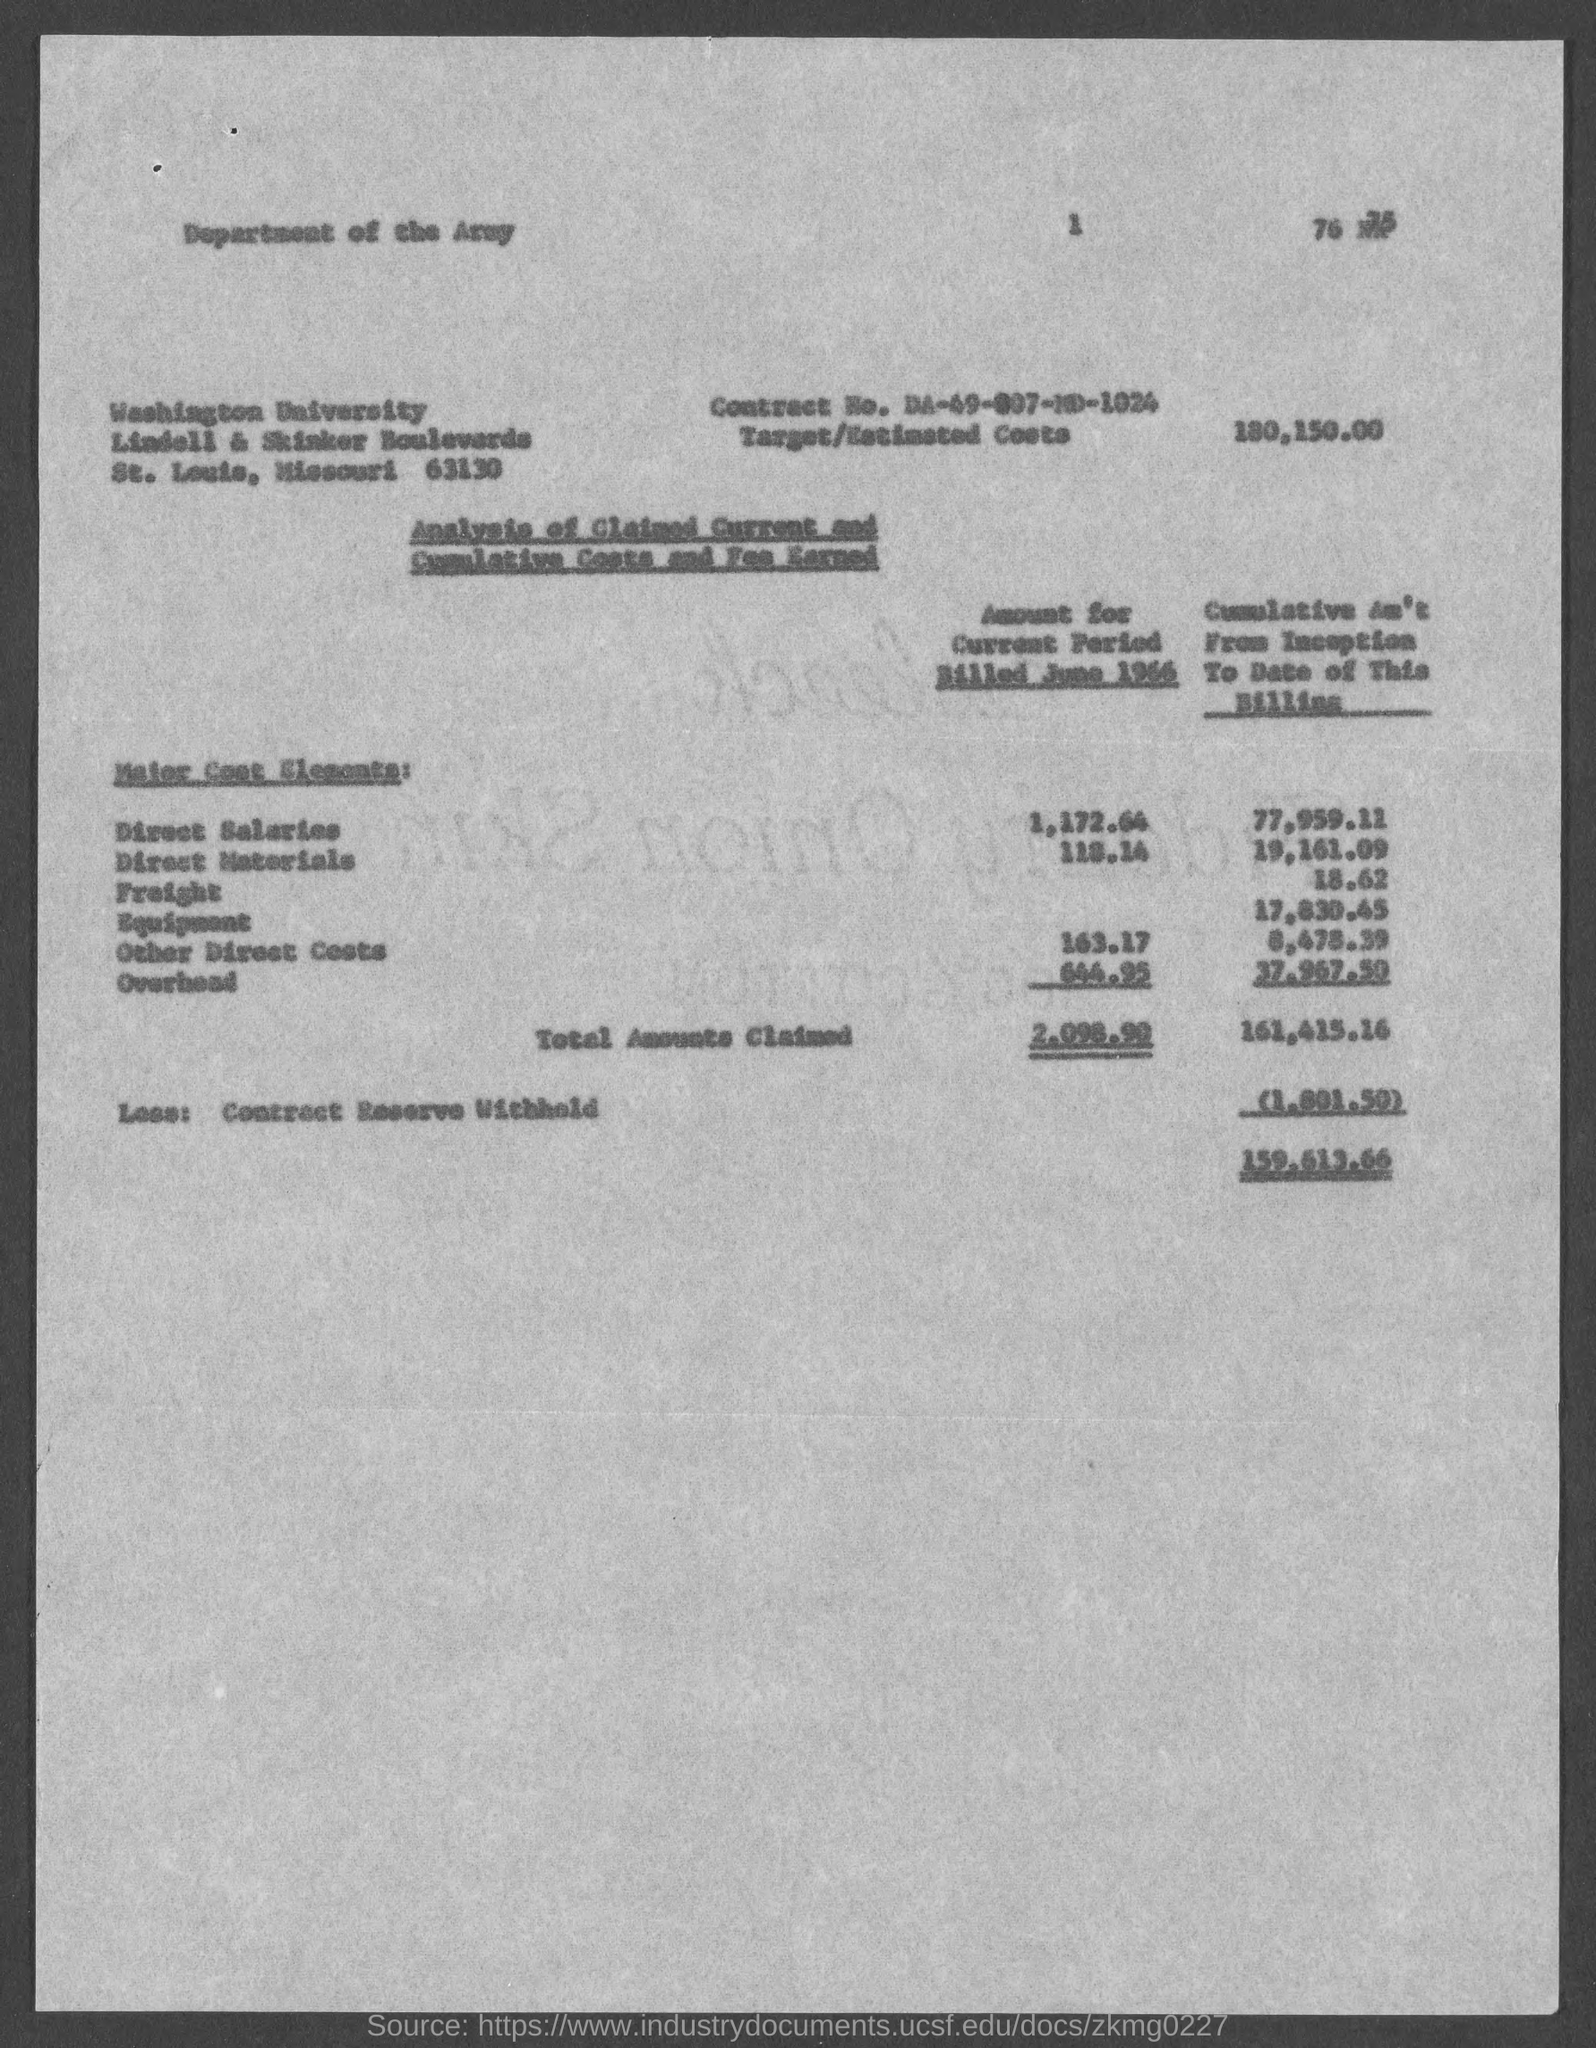In which state is washington university located ?
Give a very brief answer. Missouri. What is the contract no.?
Offer a terse response. DA-49-007-MD-1024. What is the target/ estimated costs?
Your answer should be very brief. 180,150.00. 